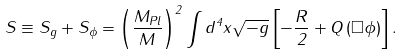Convert formula to latex. <formula><loc_0><loc_0><loc_500><loc_500>S \equiv S _ { g } + S _ { \phi } = \left ( \frac { M _ { P l } } { M } \right ) ^ { 2 } \int d ^ { 4 } x \sqrt { - g } \left [ - \frac { R } { 2 } + Q \left ( \Box \phi \right ) \right ] .</formula> 